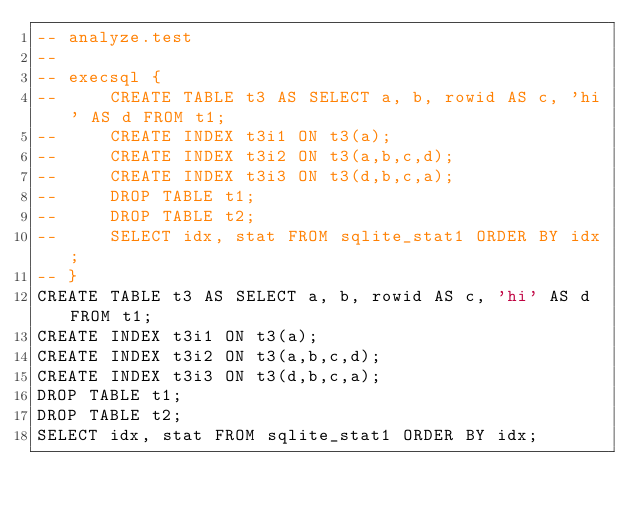<code> <loc_0><loc_0><loc_500><loc_500><_SQL_>-- analyze.test
-- 
-- execsql {
--     CREATE TABLE t3 AS SELECT a, b, rowid AS c, 'hi' AS d FROM t1;
--     CREATE INDEX t3i1 ON t3(a);
--     CREATE INDEX t3i2 ON t3(a,b,c,d);
--     CREATE INDEX t3i3 ON t3(d,b,c,a);
--     DROP TABLE t1;
--     DROP TABLE t2;
--     SELECT idx, stat FROM sqlite_stat1 ORDER BY idx;
-- }
CREATE TABLE t3 AS SELECT a, b, rowid AS c, 'hi' AS d FROM t1;
CREATE INDEX t3i1 ON t3(a);
CREATE INDEX t3i2 ON t3(a,b,c,d);
CREATE INDEX t3i3 ON t3(d,b,c,a);
DROP TABLE t1;
DROP TABLE t2;
SELECT idx, stat FROM sqlite_stat1 ORDER BY idx;</code> 